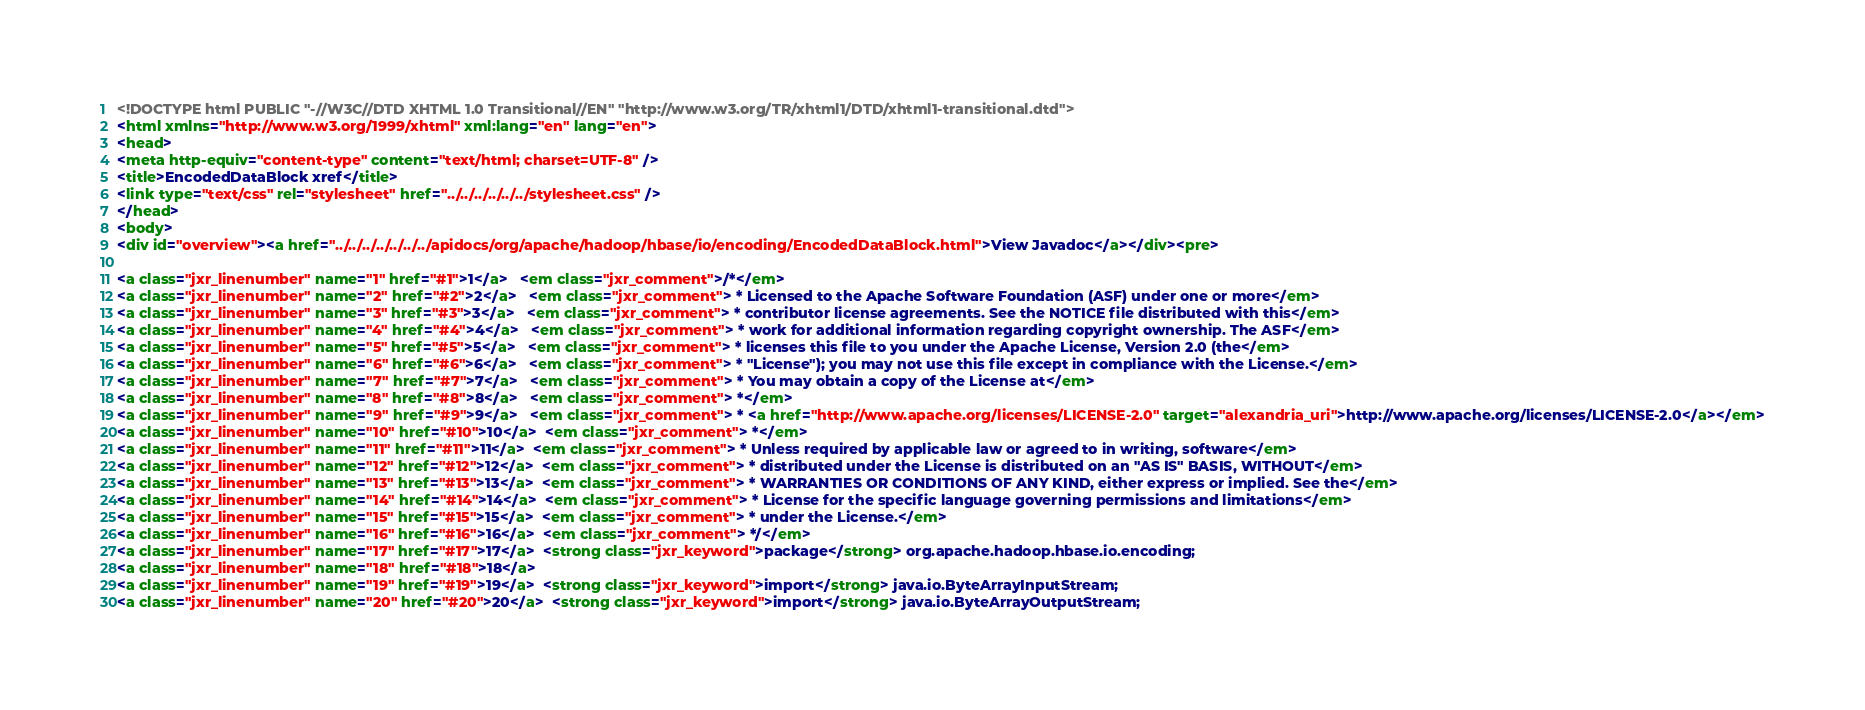Convert code to text. <code><loc_0><loc_0><loc_500><loc_500><_HTML_><!DOCTYPE html PUBLIC "-//W3C//DTD XHTML 1.0 Transitional//EN" "http://www.w3.org/TR/xhtml1/DTD/xhtml1-transitional.dtd">
<html xmlns="http://www.w3.org/1999/xhtml" xml:lang="en" lang="en">
<head>
<meta http-equiv="content-type" content="text/html; charset=UTF-8" />
<title>EncodedDataBlock xref</title>
<link type="text/css" rel="stylesheet" href="../../../../../../stylesheet.css" />
</head>
<body>
<div id="overview"><a href="../../../../../../../apidocs/org/apache/hadoop/hbase/io/encoding/EncodedDataBlock.html">View Javadoc</a></div><pre>

<a class="jxr_linenumber" name="1" href="#1">1</a>   <em class="jxr_comment">/*</em>
<a class="jxr_linenumber" name="2" href="#2">2</a>   <em class="jxr_comment"> * Licensed to the Apache Software Foundation (ASF) under one or more</em>
<a class="jxr_linenumber" name="3" href="#3">3</a>   <em class="jxr_comment"> * contributor license agreements. See the NOTICE file distributed with this</em>
<a class="jxr_linenumber" name="4" href="#4">4</a>   <em class="jxr_comment"> * work for additional information regarding copyright ownership. The ASF</em>
<a class="jxr_linenumber" name="5" href="#5">5</a>   <em class="jxr_comment"> * licenses this file to you under the Apache License, Version 2.0 (the</em>
<a class="jxr_linenumber" name="6" href="#6">6</a>   <em class="jxr_comment"> * "License"); you may not use this file except in compliance with the License.</em>
<a class="jxr_linenumber" name="7" href="#7">7</a>   <em class="jxr_comment"> * You may obtain a copy of the License at</em>
<a class="jxr_linenumber" name="8" href="#8">8</a>   <em class="jxr_comment"> *</em>
<a class="jxr_linenumber" name="9" href="#9">9</a>   <em class="jxr_comment"> * <a href="http://www.apache.org/licenses/LICENSE-2.0" target="alexandria_uri">http://www.apache.org/licenses/LICENSE-2.0</a></em>
<a class="jxr_linenumber" name="10" href="#10">10</a>  <em class="jxr_comment"> *</em>
<a class="jxr_linenumber" name="11" href="#11">11</a>  <em class="jxr_comment"> * Unless required by applicable law or agreed to in writing, software</em>
<a class="jxr_linenumber" name="12" href="#12">12</a>  <em class="jxr_comment"> * distributed under the License is distributed on an "AS IS" BASIS, WITHOUT</em>
<a class="jxr_linenumber" name="13" href="#13">13</a>  <em class="jxr_comment"> * WARRANTIES OR CONDITIONS OF ANY KIND, either express or implied. See the</em>
<a class="jxr_linenumber" name="14" href="#14">14</a>  <em class="jxr_comment"> * License for the specific language governing permissions and limitations</em>
<a class="jxr_linenumber" name="15" href="#15">15</a>  <em class="jxr_comment"> * under the License.</em>
<a class="jxr_linenumber" name="16" href="#16">16</a>  <em class="jxr_comment"> */</em>
<a class="jxr_linenumber" name="17" href="#17">17</a>  <strong class="jxr_keyword">package</strong> org.apache.hadoop.hbase.io.encoding;
<a class="jxr_linenumber" name="18" href="#18">18</a>  
<a class="jxr_linenumber" name="19" href="#19">19</a>  <strong class="jxr_keyword">import</strong> java.io.ByteArrayInputStream;
<a class="jxr_linenumber" name="20" href="#20">20</a>  <strong class="jxr_keyword">import</strong> java.io.ByteArrayOutputStream;</code> 